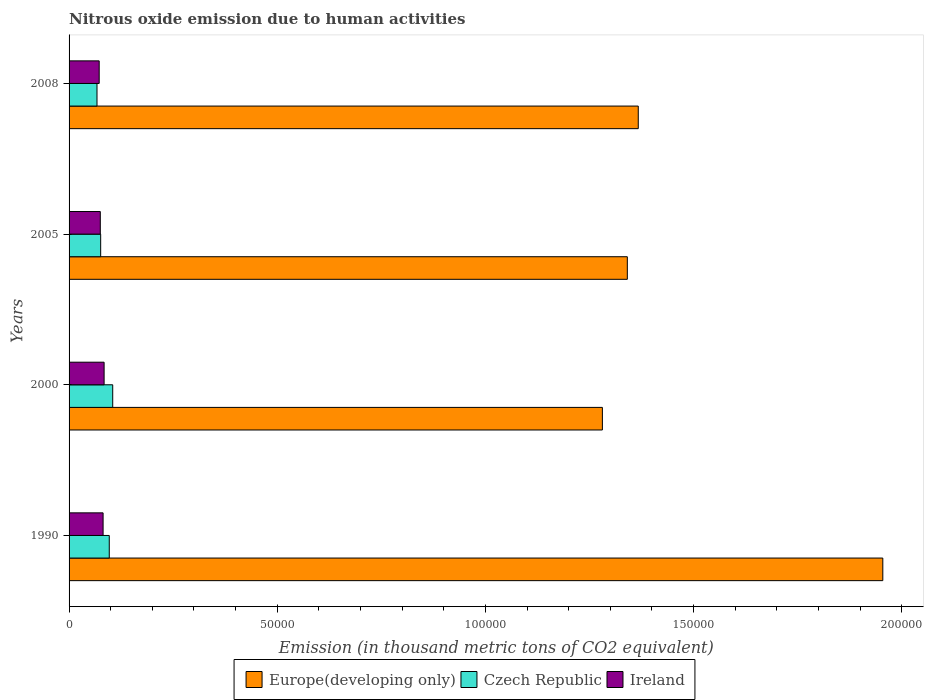How many different coloured bars are there?
Provide a short and direct response. 3. Are the number of bars per tick equal to the number of legend labels?
Your answer should be compact. Yes. Are the number of bars on each tick of the Y-axis equal?
Make the answer very short. Yes. How many bars are there on the 4th tick from the top?
Provide a short and direct response. 3. How many bars are there on the 2nd tick from the bottom?
Ensure brevity in your answer.  3. What is the amount of nitrous oxide emitted in Europe(developing only) in 1990?
Ensure brevity in your answer.  1.95e+05. Across all years, what is the maximum amount of nitrous oxide emitted in Europe(developing only)?
Provide a succinct answer. 1.95e+05. Across all years, what is the minimum amount of nitrous oxide emitted in Czech Republic?
Make the answer very short. 6709.7. In which year was the amount of nitrous oxide emitted in Czech Republic minimum?
Provide a succinct answer. 2008. What is the total amount of nitrous oxide emitted in Europe(developing only) in the graph?
Offer a terse response. 5.94e+05. What is the difference between the amount of nitrous oxide emitted in Ireland in 1990 and that in 2008?
Keep it short and to the point. 938.4. What is the difference between the amount of nitrous oxide emitted in Ireland in 2005 and the amount of nitrous oxide emitted in Czech Republic in 2000?
Provide a short and direct response. -2981.4. What is the average amount of nitrous oxide emitted in Europe(developing only) per year?
Keep it short and to the point. 1.49e+05. In the year 2005, what is the difference between the amount of nitrous oxide emitted in Ireland and amount of nitrous oxide emitted in Europe(developing only)?
Your answer should be compact. -1.27e+05. In how many years, is the amount of nitrous oxide emitted in Czech Republic greater than 30000 thousand metric tons?
Give a very brief answer. 0. What is the ratio of the amount of nitrous oxide emitted in Czech Republic in 2000 to that in 2008?
Your answer should be very brief. 1.56. What is the difference between the highest and the second highest amount of nitrous oxide emitted in Ireland?
Keep it short and to the point. 243.6. What is the difference between the highest and the lowest amount of nitrous oxide emitted in Czech Republic?
Provide a short and direct response. 3773.3. In how many years, is the amount of nitrous oxide emitted in Europe(developing only) greater than the average amount of nitrous oxide emitted in Europe(developing only) taken over all years?
Keep it short and to the point. 1. What does the 3rd bar from the top in 2008 represents?
Provide a succinct answer. Europe(developing only). What does the 2nd bar from the bottom in 2005 represents?
Ensure brevity in your answer.  Czech Republic. Is it the case that in every year, the sum of the amount of nitrous oxide emitted in Europe(developing only) and amount of nitrous oxide emitted in Czech Republic is greater than the amount of nitrous oxide emitted in Ireland?
Provide a succinct answer. Yes. How many bars are there?
Keep it short and to the point. 12. Are all the bars in the graph horizontal?
Your answer should be very brief. Yes. What is the difference between two consecutive major ticks on the X-axis?
Offer a very short reply. 5.00e+04. Does the graph contain any zero values?
Keep it short and to the point. No. Does the graph contain grids?
Your response must be concise. No. Where does the legend appear in the graph?
Keep it short and to the point. Bottom center. How are the legend labels stacked?
Make the answer very short. Horizontal. What is the title of the graph?
Offer a very short reply. Nitrous oxide emission due to human activities. What is the label or title of the X-axis?
Offer a terse response. Emission (in thousand metric tons of CO2 equivalent). What is the Emission (in thousand metric tons of CO2 equivalent) of Europe(developing only) in 1990?
Provide a succinct answer. 1.95e+05. What is the Emission (in thousand metric tons of CO2 equivalent) in Czech Republic in 1990?
Give a very brief answer. 9654. What is the Emission (in thousand metric tons of CO2 equivalent) in Ireland in 1990?
Your answer should be compact. 8172.1. What is the Emission (in thousand metric tons of CO2 equivalent) of Europe(developing only) in 2000?
Your response must be concise. 1.28e+05. What is the Emission (in thousand metric tons of CO2 equivalent) in Czech Republic in 2000?
Keep it short and to the point. 1.05e+04. What is the Emission (in thousand metric tons of CO2 equivalent) of Ireland in 2000?
Give a very brief answer. 8415.7. What is the Emission (in thousand metric tons of CO2 equivalent) of Europe(developing only) in 2005?
Offer a terse response. 1.34e+05. What is the Emission (in thousand metric tons of CO2 equivalent) in Czech Republic in 2005?
Provide a short and direct response. 7590.3. What is the Emission (in thousand metric tons of CO2 equivalent) of Ireland in 2005?
Provide a short and direct response. 7501.6. What is the Emission (in thousand metric tons of CO2 equivalent) in Europe(developing only) in 2008?
Ensure brevity in your answer.  1.37e+05. What is the Emission (in thousand metric tons of CO2 equivalent) of Czech Republic in 2008?
Keep it short and to the point. 6709.7. What is the Emission (in thousand metric tons of CO2 equivalent) in Ireland in 2008?
Offer a terse response. 7233.7. Across all years, what is the maximum Emission (in thousand metric tons of CO2 equivalent) in Europe(developing only)?
Provide a short and direct response. 1.95e+05. Across all years, what is the maximum Emission (in thousand metric tons of CO2 equivalent) in Czech Republic?
Your answer should be very brief. 1.05e+04. Across all years, what is the maximum Emission (in thousand metric tons of CO2 equivalent) of Ireland?
Your response must be concise. 8415.7. Across all years, what is the minimum Emission (in thousand metric tons of CO2 equivalent) of Europe(developing only)?
Provide a short and direct response. 1.28e+05. Across all years, what is the minimum Emission (in thousand metric tons of CO2 equivalent) in Czech Republic?
Make the answer very short. 6709.7. Across all years, what is the minimum Emission (in thousand metric tons of CO2 equivalent) in Ireland?
Offer a very short reply. 7233.7. What is the total Emission (in thousand metric tons of CO2 equivalent) in Europe(developing only) in the graph?
Provide a succinct answer. 5.94e+05. What is the total Emission (in thousand metric tons of CO2 equivalent) in Czech Republic in the graph?
Keep it short and to the point. 3.44e+04. What is the total Emission (in thousand metric tons of CO2 equivalent) in Ireland in the graph?
Ensure brevity in your answer.  3.13e+04. What is the difference between the Emission (in thousand metric tons of CO2 equivalent) of Europe(developing only) in 1990 and that in 2000?
Offer a terse response. 6.74e+04. What is the difference between the Emission (in thousand metric tons of CO2 equivalent) in Czech Republic in 1990 and that in 2000?
Your answer should be compact. -829. What is the difference between the Emission (in thousand metric tons of CO2 equivalent) in Ireland in 1990 and that in 2000?
Make the answer very short. -243.6. What is the difference between the Emission (in thousand metric tons of CO2 equivalent) in Europe(developing only) in 1990 and that in 2005?
Offer a terse response. 6.14e+04. What is the difference between the Emission (in thousand metric tons of CO2 equivalent) in Czech Republic in 1990 and that in 2005?
Provide a succinct answer. 2063.7. What is the difference between the Emission (in thousand metric tons of CO2 equivalent) of Ireland in 1990 and that in 2005?
Provide a succinct answer. 670.5. What is the difference between the Emission (in thousand metric tons of CO2 equivalent) in Europe(developing only) in 1990 and that in 2008?
Give a very brief answer. 5.87e+04. What is the difference between the Emission (in thousand metric tons of CO2 equivalent) of Czech Republic in 1990 and that in 2008?
Keep it short and to the point. 2944.3. What is the difference between the Emission (in thousand metric tons of CO2 equivalent) in Ireland in 1990 and that in 2008?
Offer a terse response. 938.4. What is the difference between the Emission (in thousand metric tons of CO2 equivalent) of Europe(developing only) in 2000 and that in 2005?
Make the answer very short. -5992.3. What is the difference between the Emission (in thousand metric tons of CO2 equivalent) in Czech Republic in 2000 and that in 2005?
Your answer should be very brief. 2892.7. What is the difference between the Emission (in thousand metric tons of CO2 equivalent) in Ireland in 2000 and that in 2005?
Your response must be concise. 914.1. What is the difference between the Emission (in thousand metric tons of CO2 equivalent) in Europe(developing only) in 2000 and that in 2008?
Offer a very short reply. -8618.7. What is the difference between the Emission (in thousand metric tons of CO2 equivalent) in Czech Republic in 2000 and that in 2008?
Offer a very short reply. 3773.3. What is the difference between the Emission (in thousand metric tons of CO2 equivalent) in Ireland in 2000 and that in 2008?
Provide a short and direct response. 1182. What is the difference between the Emission (in thousand metric tons of CO2 equivalent) in Europe(developing only) in 2005 and that in 2008?
Your answer should be compact. -2626.4. What is the difference between the Emission (in thousand metric tons of CO2 equivalent) of Czech Republic in 2005 and that in 2008?
Make the answer very short. 880.6. What is the difference between the Emission (in thousand metric tons of CO2 equivalent) of Ireland in 2005 and that in 2008?
Your answer should be compact. 267.9. What is the difference between the Emission (in thousand metric tons of CO2 equivalent) in Europe(developing only) in 1990 and the Emission (in thousand metric tons of CO2 equivalent) in Czech Republic in 2000?
Provide a short and direct response. 1.85e+05. What is the difference between the Emission (in thousand metric tons of CO2 equivalent) in Europe(developing only) in 1990 and the Emission (in thousand metric tons of CO2 equivalent) in Ireland in 2000?
Ensure brevity in your answer.  1.87e+05. What is the difference between the Emission (in thousand metric tons of CO2 equivalent) in Czech Republic in 1990 and the Emission (in thousand metric tons of CO2 equivalent) in Ireland in 2000?
Provide a succinct answer. 1238.3. What is the difference between the Emission (in thousand metric tons of CO2 equivalent) of Europe(developing only) in 1990 and the Emission (in thousand metric tons of CO2 equivalent) of Czech Republic in 2005?
Your answer should be very brief. 1.88e+05. What is the difference between the Emission (in thousand metric tons of CO2 equivalent) of Europe(developing only) in 1990 and the Emission (in thousand metric tons of CO2 equivalent) of Ireland in 2005?
Make the answer very short. 1.88e+05. What is the difference between the Emission (in thousand metric tons of CO2 equivalent) in Czech Republic in 1990 and the Emission (in thousand metric tons of CO2 equivalent) in Ireland in 2005?
Provide a short and direct response. 2152.4. What is the difference between the Emission (in thousand metric tons of CO2 equivalent) of Europe(developing only) in 1990 and the Emission (in thousand metric tons of CO2 equivalent) of Czech Republic in 2008?
Your response must be concise. 1.89e+05. What is the difference between the Emission (in thousand metric tons of CO2 equivalent) of Europe(developing only) in 1990 and the Emission (in thousand metric tons of CO2 equivalent) of Ireland in 2008?
Your response must be concise. 1.88e+05. What is the difference between the Emission (in thousand metric tons of CO2 equivalent) of Czech Republic in 1990 and the Emission (in thousand metric tons of CO2 equivalent) of Ireland in 2008?
Provide a succinct answer. 2420.3. What is the difference between the Emission (in thousand metric tons of CO2 equivalent) in Europe(developing only) in 2000 and the Emission (in thousand metric tons of CO2 equivalent) in Czech Republic in 2005?
Provide a succinct answer. 1.21e+05. What is the difference between the Emission (in thousand metric tons of CO2 equivalent) of Europe(developing only) in 2000 and the Emission (in thousand metric tons of CO2 equivalent) of Ireland in 2005?
Offer a terse response. 1.21e+05. What is the difference between the Emission (in thousand metric tons of CO2 equivalent) in Czech Republic in 2000 and the Emission (in thousand metric tons of CO2 equivalent) in Ireland in 2005?
Ensure brevity in your answer.  2981.4. What is the difference between the Emission (in thousand metric tons of CO2 equivalent) in Europe(developing only) in 2000 and the Emission (in thousand metric tons of CO2 equivalent) in Czech Republic in 2008?
Offer a terse response. 1.21e+05. What is the difference between the Emission (in thousand metric tons of CO2 equivalent) in Europe(developing only) in 2000 and the Emission (in thousand metric tons of CO2 equivalent) in Ireland in 2008?
Your answer should be compact. 1.21e+05. What is the difference between the Emission (in thousand metric tons of CO2 equivalent) in Czech Republic in 2000 and the Emission (in thousand metric tons of CO2 equivalent) in Ireland in 2008?
Keep it short and to the point. 3249.3. What is the difference between the Emission (in thousand metric tons of CO2 equivalent) in Europe(developing only) in 2005 and the Emission (in thousand metric tons of CO2 equivalent) in Czech Republic in 2008?
Keep it short and to the point. 1.27e+05. What is the difference between the Emission (in thousand metric tons of CO2 equivalent) in Europe(developing only) in 2005 and the Emission (in thousand metric tons of CO2 equivalent) in Ireland in 2008?
Make the answer very short. 1.27e+05. What is the difference between the Emission (in thousand metric tons of CO2 equivalent) in Czech Republic in 2005 and the Emission (in thousand metric tons of CO2 equivalent) in Ireland in 2008?
Make the answer very short. 356.6. What is the average Emission (in thousand metric tons of CO2 equivalent) in Europe(developing only) per year?
Your answer should be very brief. 1.49e+05. What is the average Emission (in thousand metric tons of CO2 equivalent) of Czech Republic per year?
Your answer should be compact. 8609.25. What is the average Emission (in thousand metric tons of CO2 equivalent) of Ireland per year?
Ensure brevity in your answer.  7830.77. In the year 1990, what is the difference between the Emission (in thousand metric tons of CO2 equivalent) in Europe(developing only) and Emission (in thousand metric tons of CO2 equivalent) in Czech Republic?
Keep it short and to the point. 1.86e+05. In the year 1990, what is the difference between the Emission (in thousand metric tons of CO2 equivalent) of Europe(developing only) and Emission (in thousand metric tons of CO2 equivalent) of Ireland?
Offer a very short reply. 1.87e+05. In the year 1990, what is the difference between the Emission (in thousand metric tons of CO2 equivalent) in Czech Republic and Emission (in thousand metric tons of CO2 equivalent) in Ireland?
Your response must be concise. 1481.9. In the year 2000, what is the difference between the Emission (in thousand metric tons of CO2 equivalent) of Europe(developing only) and Emission (in thousand metric tons of CO2 equivalent) of Czech Republic?
Keep it short and to the point. 1.18e+05. In the year 2000, what is the difference between the Emission (in thousand metric tons of CO2 equivalent) of Europe(developing only) and Emission (in thousand metric tons of CO2 equivalent) of Ireland?
Your answer should be very brief. 1.20e+05. In the year 2000, what is the difference between the Emission (in thousand metric tons of CO2 equivalent) in Czech Republic and Emission (in thousand metric tons of CO2 equivalent) in Ireland?
Give a very brief answer. 2067.3. In the year 2005, what is the difference between the Emission (in thousand metric tons of CO2 equivalent) of Europe(developing only) and Emission (in thousand metric tons of CO2 equivalent) of Czech Republic?
Your answer should be compact. 1.27e+05. In the year 2005, what is the difference between the Emission (in thousand metric tons of CO2 equivalent) in Europe(developing only) and Emission (in thousand metric tons of CO2 equivalent) in Ireland?
Offer a terse response. 1.27e+05. In the year 2005, what is the difference between the Emission (in thousand metric tons of CO2 equivalent) of Czech Republic and Emission (in thousand metric tons of CO2 equivalent) of Ireland?
Give a very brief answer. 88.7. In the year 2008, what is the difference between the Emission (in thousand metric tons of CO2 equivalent) of Europe(developing only) and Emission (in thousand metric tons of CO2 equivalent) of Czech Republic?
Keep it short and to the point. 1.30e+05. In the year 2008, what is the difference between the Emission (in thousand metric tons of CO2 equivalent) in Europe(developing only) and Emission (in thousand metric tons of CO2 equivalent) in Ireland?
Provide a short and direct response. 1.29e+05. In the year 2008, what is the difference between the Emission (in thousand metric tons of CO2 equivalent) of Czech Republic and Emission (in thousand metric tons of CO2 equivalent) of Ireland?
Provide a succinct answer. -524. What is the ratio of the Emission (in thousand metric tons of CO2 equivalent) in Europe(developing only) in 1990 to that in 2000?
Your answer should be very brief. 1.53. What is the ratio of the Emission (in thousand metric tons of CO2 equivalent) of Czech Republic in 1990 to that in 2000?
Ensure brevity in your answer.  0.92. What is the ratio of the Emission (in thousand metric tons of CO2 equivalent) in Ireland in 1990 to that in 2000?
Provide a short and direct response. 0.97. What is the ratio of the Emission (in thousand metric tons of CO2 equivalent) of Europe(developing only) in 1990 to that in 2005?
Your response must be concise. 1.46. What is the ratio of the Emission (in thousand metric tons of CO2 equivalent) of Czech Republic in 1990 to that in 2005?
Make the answer very short. 1.27. What is the ratio of the Emission (in thousand metric tons of CO2 equivalent) in Ireland in 1990 to that in 2005?
Provide a succinct answer. 1.09. What is the ratio of the Emission (in thousand metric tons of CO2 equivalent) of Europe(developing only) in 1990 to that in 2008?
Your answer should be compact. 1.43. What is the ratio of the Emission (in thousand metric tons of CO2 equivalent) of Czech Republic in 1990 to that in 2008?
Your answer should be compact. 1.44. What is the ratio of the Emission (in thousand metric tons of CO2 equivalent) of Ireland in 1990 to that in 2008?
Your response must be concise. 1.13. What is the ratio of the Emission (in thousand metric tons of CO2 equivalent) in Europe(developing only) in 2000 to that in 2005?
Your answer should be compact. 0.96. What is the ratio of the Emission (in thousand metric tons of CO2 equivalent) in Czech Republic in 2000 to that in 2005?
Give a very brief answer. 1.38. What is the ratio of the Emission (in thousand metric tons of CO2 equivalent) in Ireland in 2000 to that in 2005?
Your answer should be compact. 1.12. What is the ratio of the Emission (in thousand metric tons of CO2 equivalent) in Europe(developing only) in 2000 to that in 2008?
Keep it short and to the point. 0.94. What is the ratio of the Emission (in thousand metric tons of CO2 equivalent) of Czech Republic in 2000 to that in 2008?
Make the answer very short. 1.56. What is the ratio of the Emission (in thousand metric tons of CO2 equivalent) in Ireland in 2000 to that in 2008?
Ensure brevity in your answer.  1.16. What is the ratio of the Emission (in thousand metric tons of CO2 equivalent) of Europe(developing only) in 2005 to that in 2008?
Your answer should be very brief. 0.98. What is the ratio of the Emission (in thousand metric tons of CO2 equivalent) of Czech Republic in 2005 to that in 2008?
Ensure brevity in your answer.  1.13. What is the difference between the highest and the second highest Emission (in thousand metric tons of CO2 equivalent) in Europe(developing only)?
Provide a succinct answer. 5.87e+04. What is the difference between the highest and the second highest Emission (in thousand metric tons of CO2 equivalent) of Czech Republic?
Make the answer very short. 829. What is the difference between the highest and the second highest Emission (in thousand metric tons of CO2 equivalent) of Ireland?
Provide a short and direct response. 243.6. What is the difference between the highest and the lowest Emission (in thousand metric tons of CO2 equivalent) in Europe(developing only)?
Offer a very short reply. 6.74e+04. What is the difference between the highest and the lowest Emission (in thousand metric tons of CO2 equivalent) of Czech Republic?
Your response must be concise. 3773.3. What is the difference between the highest and the lowest Emission (in thousand metric tons of CO2 equivalent) of Ireland?
Your answer should be very brief. 1182. 